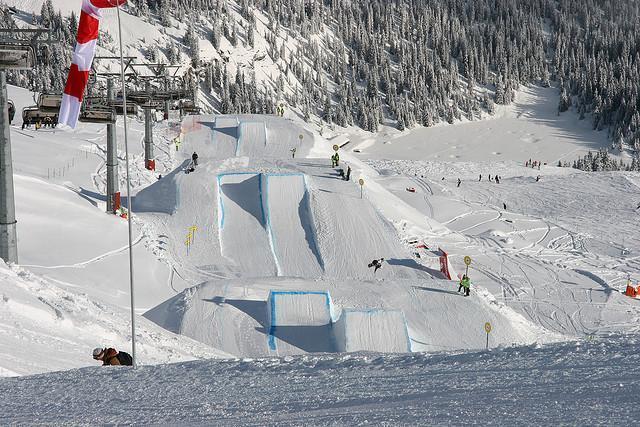How many suitcases are on the belt?
Give a very brief answer. 0. 